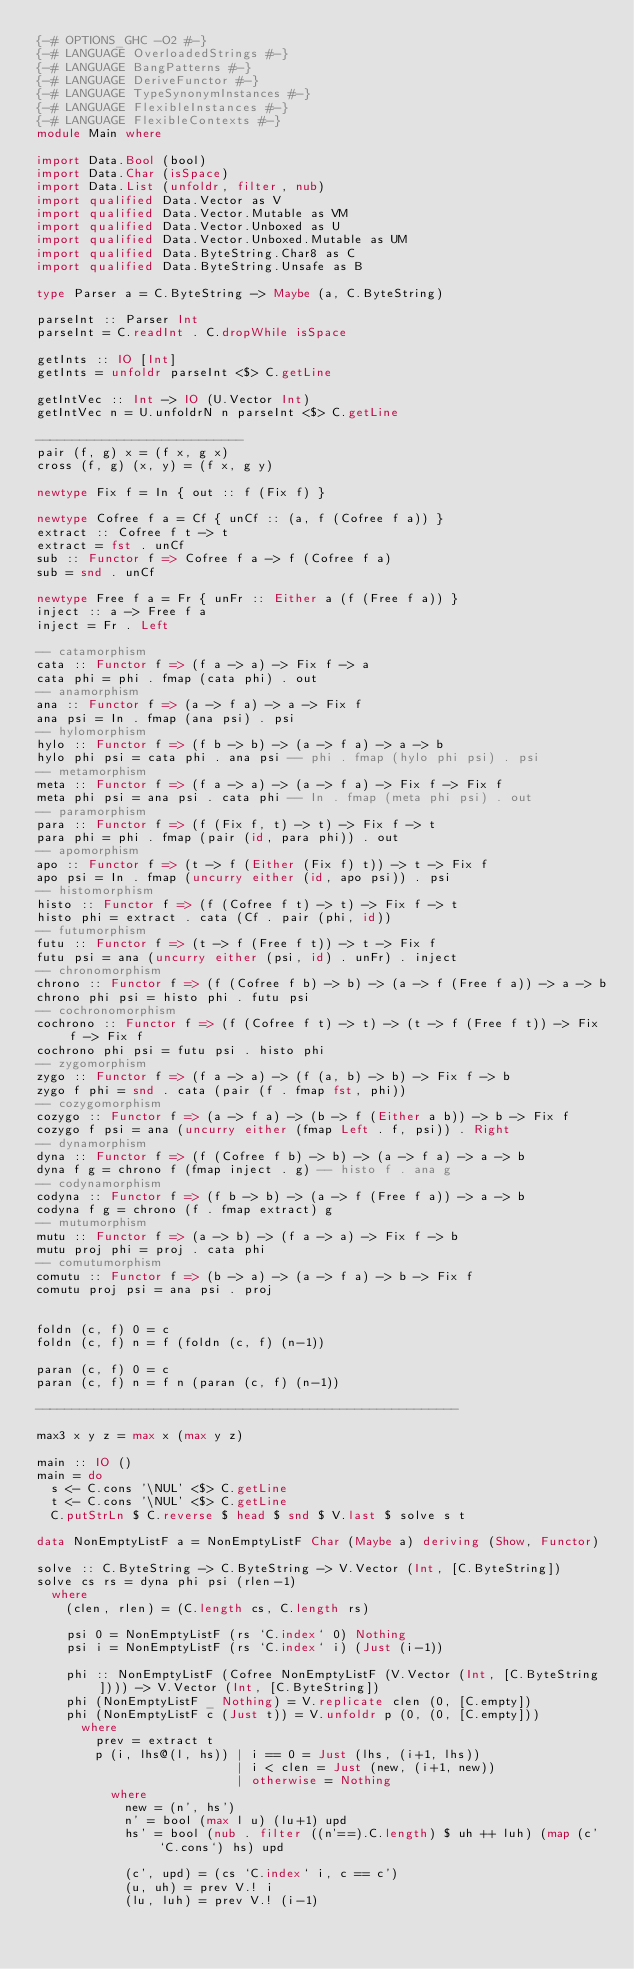<code> <loc_0><loc_0><loc_500><loc_500><_Haskell_>{-# OPTIONS_GHC -O2 #-}
{-# LANGUAGE OverloadedStrings #-}
{-# LANGUAGE BangPatterns #-}
{-# LANGUAGE DeriveFunctor #-}
{-# LANGUAGE TypeSynonymInstances #-}
{-# LANGUAGE FlexibleInstances #-}
{-# LANGUAGE FlexibleContexts #-}
module Main where

import Data.Bool (bool)
import Data.Char (isSpace)
import Data.List (unfoldr, filter, nub)
import qualified Data.Vector as V
import qualified Data.Vector.Mutable as VM
import qualified Data.Vector.Unboxed as U
import qualified Data.Vector.Unboxed.Mutable as UM
import qualified Data.ByteString.Char8 as C
import qualified Data.ByteString.Unsafe as B

type Parser a = C.ByteString -> Maybe (a, C.ByteString)

parseInt :: Parser Int
parseInt = C.readInt . C.dropWhile isSpace

getInts :: IO [Int]
getInts = unfoldr parseInt <$> C.getLine

getIntVec :: Int -> IO (U.Vector Int)
getIntVec n = U.unfoldrN n parseInt <$> C.getLine

----------------------------
pair (f, g) x = (f x, g x)
cross (f, g) (x, y) = (f x, g y)

newtype Fix f = In { out :: f (Fix f) }

newtype Cofree f a = Cf { unCf :: (a, f (Cofree f a)) }
extract :: Cofree f t -> t
extract = fst . unCf
sub :: Functor f => Cofree f a -> f (Cofree f a)
sub = snd . unCf

newtype Free f a = Fr { unFr :: Either a (f (Free f a)) }
inject :: a -> Free f a
inject = Fr . Left

-- catamorphism
cata :: Functor f => (f a -> a) -> Fix f -> a
cata phi = phi . fmap (cata phi) . out
-- anamorphism
ana :: Functor f => (a -> f a) -> a -> Fix f
ana psi = In . fmap (ana psi) . psi
-- hylomorphism
hylo :: Functor f => (f b -> b) -> (a -> f a) -> a -> b
hylo phi psi = cata phi . ana psi -- phi . fmap (hylo phi psi) . psi
-- metamorphism
meta :: Functor f => (f a -> a) -> (a -> f a) -> Fix f -> Fix f
meta phi psi = ana psi . cata phi -- In . fmap (meta phi psi) . out
-- paramorphism
para :: Functor f => (f (Fix f, t) -> t) -> Fix f -> t
para phi = phi . fmap (pair (id, para phi)) . out
-- apomorphism
apo :: Functor f => (t -> f (Either (Fix f) t)) -> t -> Fix f
apo psi = In . fmap (uncurry either (id, apo psi)) . psi
-- histomorphism
histo :: Functor f => (f (Cofree f t) -> t) -> Fix f -> t
histo phi = extract . cata (Cf . pair (phi, id))
-- futumorphism
futu :: Functor f => (t -> f (Free f t)) -> t -> Fix f
futu psi = ana (uncurry either (psi, id) . unFr) . inject
-- chronomorphism
chrono :: Functor f => (f (Cofree f b) -> b) -> (a -> f (Free f a)) -> a -> b
chrono phi psi = histo phi . futu psi
-- cochronomorphism
cochrono :: Functor f => (f (Cofree f t) -> t) -> (t -> f (Free f t)) -> Fix f -> Fix f
cochrono phi psi = futu psi . histo phi
-- zygomorphism
zygo :: Functor f => (f a -> a) -> (f (a, b) -> b) -> Fix f -> b
zygo f phi = snd . cata (pair (f . fmap fst, phi))
-- cozygomorphism
cozygo :: Functor f => (a -> f a) -> (b -> f (Either a b)) -> b -> Fix f
cozygo f psi = ana (uncurry either (fmap Left . f, psi)) . Right
-- dynamorphism
dyna :: Functor f => (f (Cofree f b) -> b) -> (a -> f a) -> a -> b
dyna f g = chrono f (fmap inject . g) -- histo f . ana g
-- codynamorphism
codyna :: Functor f => (f b -> b) -> (a -> f (Free f a)) -> a -> b
codyna f g = chrono (f . fmap extract) g
-- mutumorphism
mutu :: Functor f => (a -> b) -> (f a -> a) -> Fix f -> b
mutu proj phi = proj . cata phi
-- comutumorphism
comutu :: Functor f => (b -> a) -> (a -> f a) -> b -> Fix f
comutu proj psi = ana psi . proj


foldn (c, f) 0 = c
foldn (c, f) n = f (foldn (c, f) (n-1))

paran (c, f) 0 = c
paran (c, f) n = f n (paran (c, f) (n-1))

---------------------------------------------------------

max3 x y z = max x (max y z)

main :: IO ()
main = do
  s <- C.cons '\NUL' <$> C.getLine
  t <- C.cons '\NUL' <$> C.getLine
  C.putStrLn $ C.reverse $ head $ snd $ V.last $ solve s t

data NonEmptyListF a = NonEmptyListF Char (Maybe a) deriving (Show, Functor)

solve :: C.ByteString -> C.ByteString -> V.Vector (Int, [C.ByteString])
solve cs rs = dyna phi psi (rlen-1)
  where
    (clen, rlen) = (C.length cs, C.length rs)
    
    psi 0 = NonEmptyListF (rs `C.index` 0) Nothing
    psi i = NonEmptyListF (rs `C.index` i) (Just (i-1))

    phi :: NonEmptyListF (Cofree NonEmptyListF (V.Vector (Int, [C.ByteString]))) -> V.Vector (Int, [C.ByteString])
    phi (NonEmptyListF _ Nothing) = V.replicate clen (0, [C.empty])
    phi (NonEmptyListF c (Just t)) = V.unfoldr p (0, (0, [C.empty]))
      where
        prev = extract t
        p (i, lhs@(l, hs)) | i == 0 = Just (lhs, (i+1, lhs))
                           | i < clen = Just (new, (i+1, new))
                           | otherwise = Nothing
          where
            new = (n', hs')            
            n' = bool (max l u) (lu+1) upd
            hs' = bool (nub . filter ((n'==).C.length) $ uh ++ luh) (map (c' `C.cons`) hs) upd
            
            (c', upd) = (cs `C.index` i, c == c')
            (u, uh) = prev V.! i
            (lu, luh) = prev V.! (i-1)
</code> 